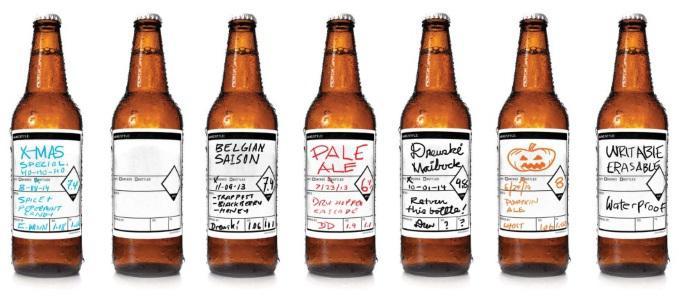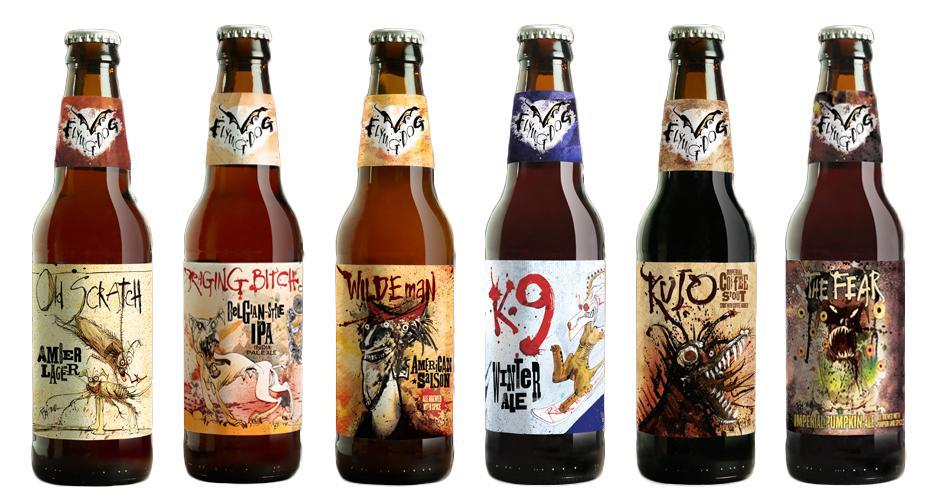The first image is the image on the left, the second image is the image on the right. Analyze the images presented: Is the assertion "One image contains only two containers of beer." valid? Answer yes or no. No. The first image is the image on the left, the second image is the image on the right. Considering the images on both sides, is "One of the images shows a glass next to a bottle of beer and the other image shows a row of beer bottles." valid? Answer yes or no. No. 